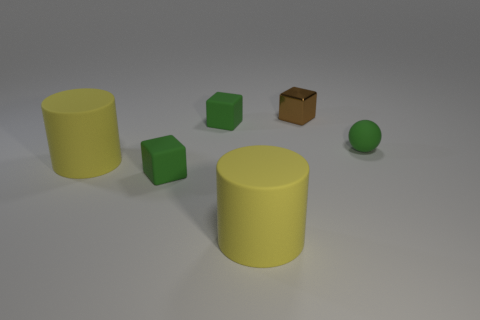Is there any other thing that is the same color as the small metal thing?
Offer a very short reply. No. Does the rubber thing on the right side of the brown shiny object have the same size as the brown shiny thing?
Offer a terse response. Yes. There is a block that is behind the green object that is behind the green matte sphere that is to the right of the tiny brown metallic block; what color is it?
Provide a short and direct response. Brown. What color is the sphere?
Your response must be concise. Green. Is the material of the thing that is to the right of the brown metal thing the same as the tiny green object in front of the tiny green ball?
Offer a very short reply. Yes. Is the ball made of the same material as the small brown cube?
Provide a succinct answer. No. There is a cylinder behind the tiny green block in front of the green matte sphere; what color is it?
Your answer should be very brief. Yellow. What number of other small things are the same shape as the tiny metallic object?
Provide a short and direct response. 2. How many things are either tiny rubber objects to the left of the small shiny block or tiny objects that are behind the small sphere?
Offer a terse response. 3. How many small brown shiny things are to the left of the tiny green object that is to the right of the brown metallic cube?
Offer a very short reply. 1. 